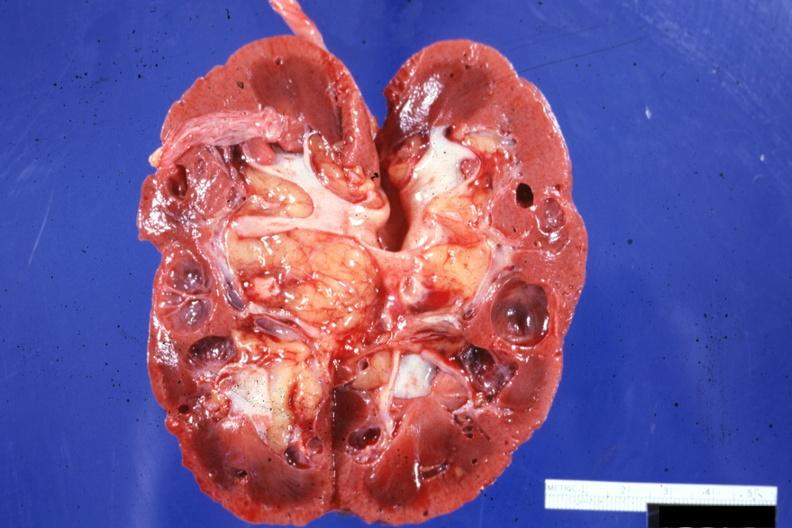does serous cystadenoma show cut surface?
Answer the question using a single word or phrase. No 